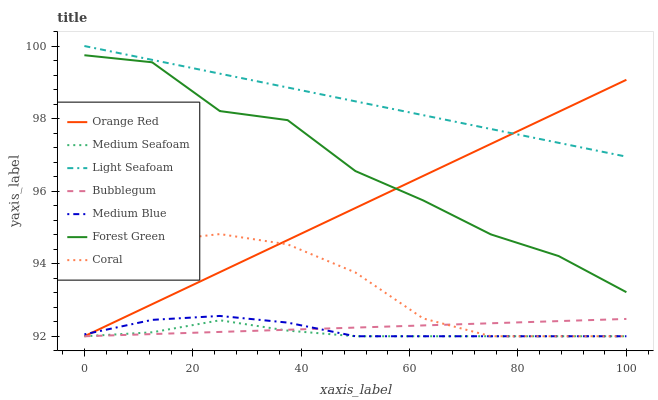Does Medium Seafoam have the minimum area under the curve?
Answer yes or no. Yes. Does Light Seafoam have the maximum area under the curve?
Answer yes or no. Yes. Does Medium Blue have the minimum area under the curve?
Answer yes or no. No. Does Medium Blue have the maximum area under the curve?
Answer yes or no. No. Is Bubblegum the smoothest?
Answer yes or no. Yes. Is Forest Green the roughest?
Answer yes or no. Yes. Is Medium Blue the smoothest?
Answer yes or no. No. Is Medium Blue the roughest?
Answer yes or no. No. Does Coral have the lowest value?
Answer yes or no. Yes. Does Forest Green have the lowest value?
Answer yes or no. No. Does Light Seafoam have the highest value?
Answer yes or no. Yes. Does Medium Blue have the highest value?
Answer yes or no. No. Is Coral less than Forest Green?
Answer yes or no. Yes. Is Light Seafoam greater than Forest Green?
Answer yes or no. Yes. Does Medium Blue intersect Coral?
Answer yes or no. Yes. Is Medium Blue less than Coral?
Answer yes or no. No. Is Medium Blue greater than Coral?
Answer yes or no. No. Does Coral intersect Forest Green?
Answer yes or no. No. 